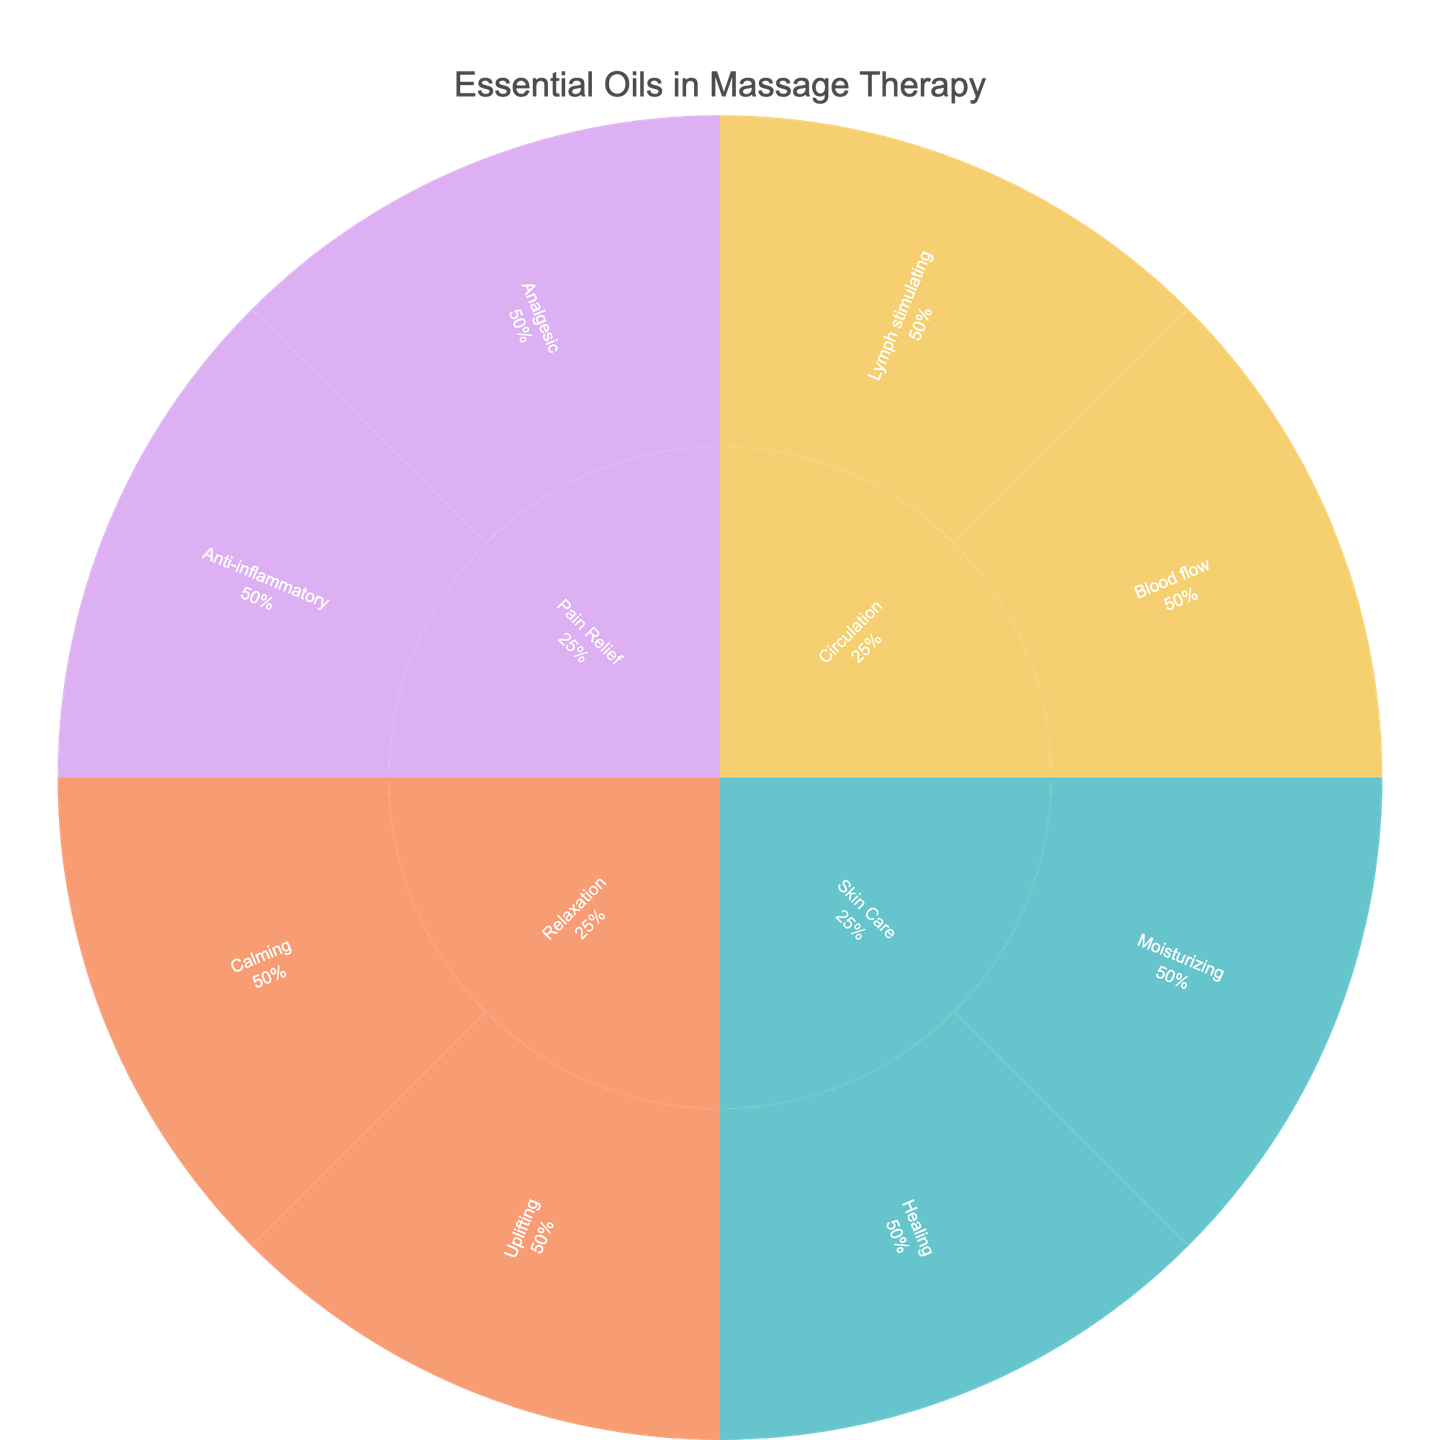What's the title of the sunburst plot? The title of the plot is displayed at the top in a larger and bolder font compared to other text in the figure.
Answer: Essential Oils in Massage Therapy How many subcategories are there in the "Circulation" category? To find this, look for the "Circulation" category in the sunburst plot and count the connected subcategories.
Answer: 2 Which category has the oil "Frankincense"? You need to find the label "Frankincense" in the plot, trace back to its subcategory and then to its main category.
Answer: Pain Relief How many oils are used for "Moisturizing" in "Skin Care"? Locate the "Moisturizing" subcategory under "Skin Care" and count the oils listed under this subcategory.
Answer: 2 Which categories have more than two subcategories? Inspect each category and count their subcategories. Only "Relaxation" has more than two subcategories.
Answer: Relaxation What's the application of "Peppermint" oil? Hover over or identify the "Peppermint" oil in the plot and read the application associated with it.
Answer: Muscle soreness Which category has the most oils listed? Identify the category labels and count the number of oils listed under each category, comparing to find the highest count.
Answer: Relaxation Compare the applications of "Cypress" and "Juniper Berry". Are they similar or different? Locate both "Cypress" and "Juniper Berry" in the plot and note their applications to assess similarity. Both are used for different aspects of lymph stimulation in circulation.
Answer: Similar How many oils are used for "Anti-inflammatory" purposes under the "Pain Relief" category? Locate the "Anti-inflammatory" subcategory under "Pain Relief" and count the oils listed under this subcategory.
Answer: 2 Which oil is used for "Cold extremities" and under which category does it fall? Identify the oil associated with the application "Cold extremities" and trace its category.
Answer: Black Pepper, Circulation 